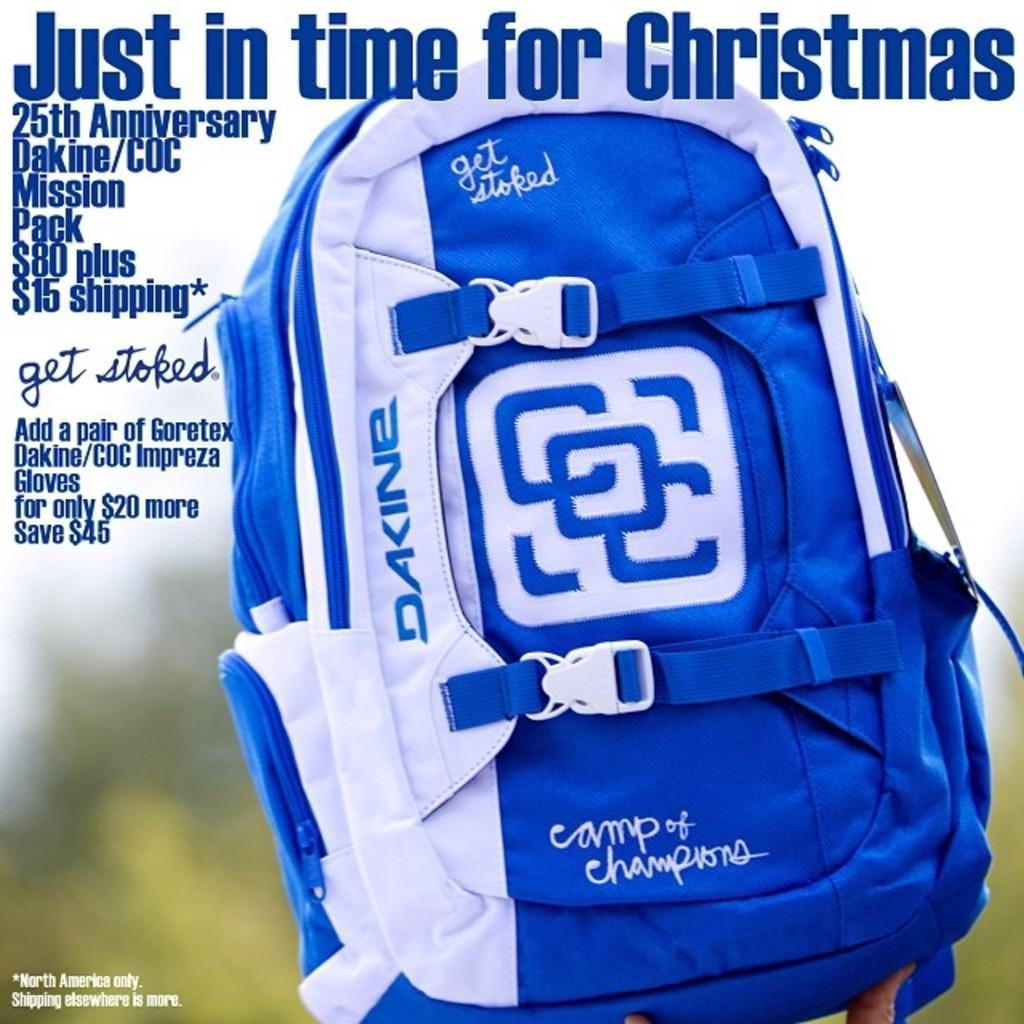<image>
Render a clear and concise summary of the photo. Just in time for christmas poster with a blue book bag 